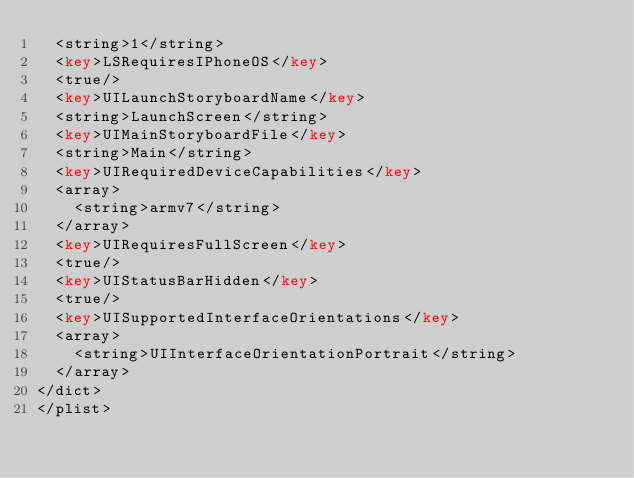Convert code to text. <code><loc_0><loc_0><loc_500><loc_500><_XML_>	<string>1</string>
	<key>LSRequiresIPhoneOS</key>
	<true/>
	<key>UILaunchStoryboardName</key>
	<string>LaunchScreen</string>
	<key>UIMainStoryboardFile</key>
	<string>Main</string>
	<key>UIRequiredDeviceCapabilities</key>
	<array>
		<string>armv7</string>
	</array>
	<key>UIRequiresFullScreen</key>
	<true/>
	<key>UIStatusBarHidden</key>
	<true/>
	<key>UISupportedInterfaceOrientations</key>
	<array>
		<string>UIInterfaceOrientationPortrait</string>
	</array>
</dict>
</plist>
</code> 